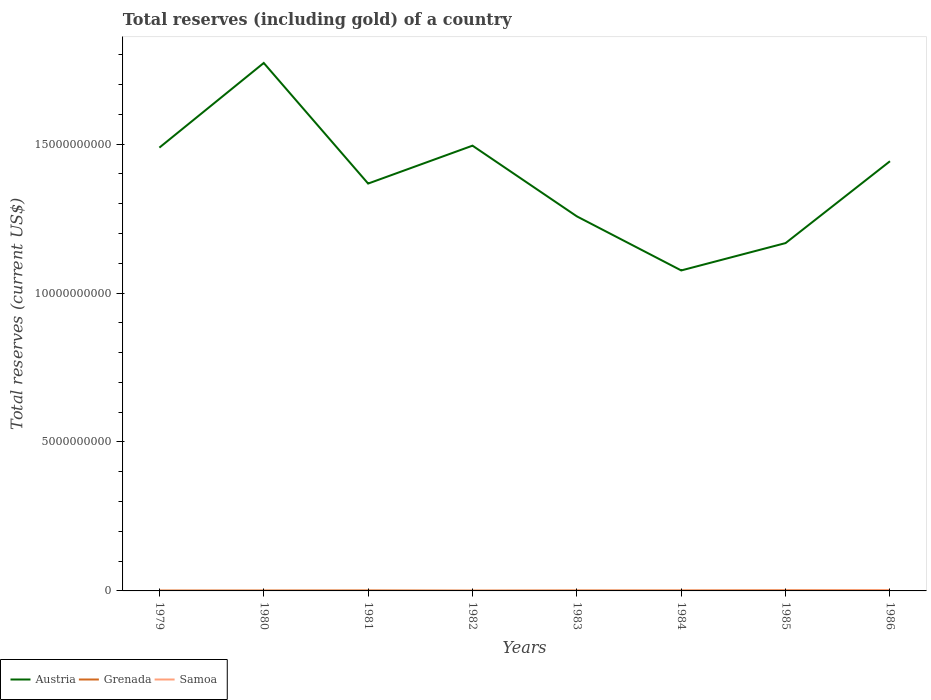How many different coloured lines are there?
Your answer should be very brief. 3. Does the line corresponding to Austria intersect with the line corresponding to Grenada?
Offer a very short reply. No. Is the number of lines equal to the number of legend labels?
Ensure brevity in your answer.  Yes. Across all years, what is the maximum total reserves (including gold) in Samoa?
Make the answer very short. 2.77e+06. What is the total total reserves (including gold) in Samoa in the graph?
Offer a very short reply. -4.46e+06. What is the difference between the highest and the second highest total reserves (including gold) in Austria?
Your answer should be very brief. 6.97e+09. What is the difference between the highest and the lowest total reserves (including gold) in Grenada?
Offer a very short reply. 3. How many years are there in the graph?
Provide a short and direct response. 8. Are the values on the major ticks of Y-axis written in scientific E-notation?
Make the answer very short. No. Does the graph contain any zero values?
Keep it short and to the point. No. Does the graph contain grids?
Keep it short and to the point. No. Where does the legend appear in the graph?
Ensure brevity in your answer.  Bottom left. What is the title of the graph?
Your answer should be compact. Total reserves (including gold) of a country. Does "Saudi Arabia" appear as one of the legend labels in the graph?
Your response must be concise. No. What is the label or title of the X-axis?
Your answer should be very brief. Years. What is the label or title of the Y-axis?
Your answer should be compact. Total reserves (current US$). What is the Total reserves (current US$) in Austria in 1979?
Your answer should be compact. 1.49e+1. What is the Total reserves (current US$) of Grenada in 1979?
Your answer should be compact. 1.22e+07. What is the Total reserves (current US$) in Samoa in 1979?
Provide a succinct answer. 4.82e+06. What is the Total reserves (current US$) of Austria in 1980?
Keep it short and to the point. 1.77e+1. What is the Total reserves (current US$) of Grenada in 1980?
Make the answer very short. 1.29e+07. What is the Total reserves (current US$) in Samoa in 1980?
Offer a very short reply. 2.77e+06. What is the Total reserves (current US$) of Austria in 1981?
Provide a succinct answer. 1.37e+1. What is the Total reserves (current US$) in Grenada in 1981?
Offer a very short reply. 1.61e+07. What is the Total reserves (current US$) in Samoa in 1981?
Ensure brevity in your answer.  3.28e+06. What is the Total reserves (current US$) in Austria in 1982?
Your answer should be very brief. 1.49e+1. What is the Total reserves (current US$) in Grenada in 1982?
Offer a terse response. 9.23e+06. What is the Total reserves (current US$) in Samoa in 1982?
Make the answer very short. 3.48e+06. What is the Total reserves (current US$) of Austria in 1983?
Make the answer very short. 1.26e+1. What is the Total reserves (current US$) in Grenada in 1983?
Make the answer very short. 1.41e+07. What is the Total reserves (current US$) of Samoa in 1983?
Your answer should be very brief. 7.23e+06. What is the Total reserves (current US$) of Austria in 1984?
Make the answer very short. 1.08e+1. What is the Total reserves (current US$) in Grenada in 1984?
Your response must be concise. 1.42e+07. What is the Total reserves (current US$) of Samoa in 1984?
Provide a short and direct response. 1.06e+07. What is the Total reserves (current US$) of Austria in 1985?
Make the answer very short. 1.17e+1. What is the Total reserves (current US$) in Grenada in 1985?
Your answer should be compact. 2.08e+07. What is the Total reserves (current US$) of Samoa in 1985?
Your response must be concise. 1.40e+07. What is the Total reserves (current US$) in Austria in 1986?
Make the answer very short. 1.44e+1. What is the Total reserves (current US$) in Grenada in 1986?
Provide a short and direct response. 2.06e+07. What is the Total reserves (current US$) of Samoa in 1986?
Offer a terse response. 2.37e+07. Across all years, what is the maximum Total reserves (current US$) in Austria?
Your answer should be very brief. 1.77e+1. Across all years, what is the maximum Total reserves (current US$) in Grenada?
Offer a terse response. 2.08e+07. Across all years, what is the maximum Total reserves (current US$) of Samoa?
Your answer should be very brief. 2.37e+07. Across all years, what is the minimum Total reserves (current US$) of Austria?
Offer a very short reply. 1.08e+1. Across all years, what is the minimum Total reserves (current US$) of Grenada?
Offer a very short reply. 9.23e+06. Across all years, what is the minimum Total reserves (current US$) of Samoa?
Ensure brevity in your answer.  2.77e+06. What is the total Total reserves (current US$) of Austria in the graph?
Provide a succinct answer. 1.11e+11. What is the total Total reserves (current US$) in Grenada in the graph?
Your response must be concise. 1.20e+08. What is the total Total reserves (current US$) of Samoa in the graph?
Make the answer very short. 6.99e+07. What is the difference between the Total reserves (current US$) of Austria in 1979 and that in 1980?
Your response must be concise. -2.84e+09. What is the difference between the Total reserves (current US$) of Grenada in 1979 and that in 1980?
Your answer should be compact. -6.89e+05. What is the difference between the Total reserves (current US$) of Samoa in 1979 and that in 1980?
Keep it short and to the point. 2.05e+06. What is the difference between the Total reserves (current US$) in Austria in 1979 and that in 1981?
Give a very brief answer. 1.21e+09. What is the difference between the Total reserves (current US$) in Grenada in 1979 and that in 1981?
Keep it short and to the point. -3.88e+06. What is the difference between the Total reserves (current US$) of Samoa in 1979 and that in 1981?
Offer a terse response. 1.54e+06. What is the difference between the Total reserves (current US$) of Austria in 1979 and that in 1982?
Offer a terse response. -6.56e+07. What is the difference between the Total reserves (current US$) in Grenada in 1979 and that in 1982?
Ensure brevity in your answer.  2.99e+06. What is the difference between the Total reserves (current US$) in Samoa in 1979 and that in 1982?
Ensure brevity in your answer.  1.34e+06. What is the difference between the Total reserves (current US$) of Austria in 1979 and that in 1983?
Offer a very short reply. 2.31e+09. What is the difference between the Total reserves (current US$) of Grenada in 1979 and that in 1983?
Your response must be concise. -1.92e+06. What is the difference between the Total reserves (current US$) of Samoa in 1979 and that in 1983?
Your response must be concise. -2.41e+06. What is the difference between the Total reserves (current US$) of Austria in 1979 and that in 1984?
Your answer should be compact. 4.12e+09. What is the difference between the Total reserves (current US$) of Grenada in 1979 and that in 1984?
Provide a succinct answer. -2.01e+06. What is the difference between the Total reserves (current US$) of Samoa in 1979 and that in 1984?
Offer a terse response. -5.74e+06. What is the difference between the Total reserves (current US$) of Austria in 1979 and that in 1985?
Provide a short and direct response. 3.21e+09. What is the difference between the Total reserves (current US$) of Grenada in 1979 and that in 1985?
Provide a short and direct response. -8.59e+06. What is the difference between the Total reserves (current US$) in Samoa in 1979 and that in 1985?
Make the answer very short. -9.20e+06. What is the difference between the Total reserves (current US$) of Austria in 1979 and that in 1986?
Your response must be concise. 4.57e+08. What is the difference between the Total reserves (current US$) of Grenada in 1979 and that in 1986?
Provide a short and direct response. -8.35e+06. What is the difference between the Total reserves (current US$) in Samoa in 1979 and that in 1986?
Give a very brief answer. -1.89e+07. What is the difference between the Total reserves (current US$) in Austria in 1980 and that in 1981?
Make the answer very short. 4.05e+09. What is the difference between the Total reserves (current US$) in Grenada in 1980 and that in 1981?
Provide a succinct answer. -3.19e+06. What is the difference between the Total reserves (current US$) in Samoa in 1980 and that in 1981?
Provide a short and direct response. -5.12e+05. What is the difference between the Total reserves (current US$) of Austria in 1980 and that in 1982?
Provide a succinct answer. 2.78e+09. What is the difference between the Total reserves (current US$) in Grenada in 1980 and that in 1982?
Provide a short and direct response. 3.68e+06. What is the difference between the Total reserves (current US$) in Samoa in 1980 and that in 1982?
Provide a short and direct response. -7.11e+05. What is the difference between the Total reserves (current US$) in Austria in 1980 and that in 1983?
Offer a terse response. 5.15e+09. What is the difference between the Total reserves (current US$) in Grenada in 1980 and that in 1983?
Ensure brevity in your answer.  -1.23e+06. What is the difference between the Total reserves (current US$) in Samoa in 1980 and that in 1983?
Your answer should be very brief. -4.46e+06. What is the difference between the Total reserves (current US$) in Austria in 1980 and that in 1984?
Keep it short and to the point. 6.97e+09. What is the difference between the Total reserves (current US$) in Grenada in 1980 and that in 1984?
Offer a very short reply. -1.33e+06. What is the difference between the Total reserves (current US$) in Samoa in 1980 and that in 1984?
Offer a terse response. -7.79e+06. What is the difference between the Total reserves (current US$) in Austria in 1980 and that in 1985?
Make the answer very short. 6.05e+09. What is the difference between the Total reserves (current US$) of Grenada in 1980 and that in 1985?
Give a very brief answer. -7.90e+06. What is the difference between the Total reserves (current US$) in Samoa in 1980 and that in 1985?
Give a very brief answer. -1.13e+07. What is the difference between the Total reserves (current US$) of Austria in 1980 and that in 1986?
Offer a terse response. 3.30e+09. What is the difference between the Total reserves (current US$) in Grenada in 1980 and that in 1986?
Offer a terse response. -7.66e+06. What is the difference between the Total reserves (current US$) in Samoa in 1980 and that in 1986?
Offer a very short reply. -2.10e+07. What is the difference between the Total reserves (current US$) of Austria in 1981 and that in 1982?
Ensure brevity in your answer.  -1.27e+09. What is the difference between the Total reserves (current US$) of Grenada in 1981 and that in 1982?
Offer a terse response. 6.86e+06. What is the difference between the Total reserves (current US$) in Samoa in 1981 and that in 1982?
Provide a short and direct response. -1.99e+05. What is the difference between the Total reserves (current US$) of Austria in 1981 and that in 1983?
Your answer should be compact. 1.10e+09. What is the difference between the Total reserves (current US$) in Grenada in 1981 and that in 1983?
Make the answer very short. 1.96e+06. What is the difference between the Total reserves (current US$) in Samoa in 1981 and that in 1983?
Your response must be concise. -3.95e+06. What is the difference between the Total reserves (current US$) in Austria in 1981 and that in 1984?
Offer a terse response. 2.92e+09. What is the difference between the Total reserves (current US$) in Grenada in 1981 and that in 1984?
Your answer should be compact. 1.86e+06. What is the difference between the Total reserves (current US$) in Samoa in 1981 and that in 1984?
Your answer should be compact. -7.28e+06. What is the difference between the Total reserves (current US$) of Austria in 1981 and that in 1985?
Offer a terse response. 2.00e+09. What is the difference between the Total reserves (current US$) of Grenada in 1981 and that in 1985?
Your response must be concise. -4.72e+06. What is the difference between the Total reserves (current US$) in Samoa in 1981 and that in 1985?
Provide a short and direct response. -1.07e+07. What is the difference between the Total reserves (current US$) in Austria in 1981 and that in 1986?
Your response must be concise. -7.50e+08. What is the difference between the Total reserves (current US$) of Grenada in 1981 and that in 1986?
Your response must be concise. -4.47e+06. What is the difference between the Total reserves (current US$) in Samoa in 1981 and that in 1986?
Offer a very short reply. -2.05e+07. What is the difference between the Total reserves (current US$) in Austria in 1982 and that in 1983?
Keep it short and to the point. 2.37e+09. What is the difference between the Total reserves (current US$) of Grenada in 1982 and that in 1983?
Keep it short and to the point. -4.91e+06. What is the difference between the Total reserves (current US$) of Samoa in 1982 and that in 1983?
Provide a short and direct response. -3.75e+06. What is the difference between the Total reserves (current US$) of Austria in 1982 and that in 1984?
Provide a succinct answer. 4.19e+09. What is the difference between the Total reserves (current US$) in Grenada in 1982 and that in 1984?
Provide a succinct answer. -5.00e+06. What is the difference between the Total reserves (current US$) of Samoa in 1982 and that in 1984?
Your answer should be compact. -7.08e+06. What is the difference between the Total reserves (current US$) of Austria in 1982 and that in 1985?
Ensure brevity in your answer.  3.27e+09. What is the difference between the Total reserves (current US$) in Grenada in 1982 and that in 1985?
Your response must be concise. -1.16e+07. What is the difference between the Total reserves (current US$) in Samoa in 1982 and that in 1985?
Give a very brief answer. -1.05e+07. What is the difference between the Total reserves (current US$) in Austria in 1982 and that in 1986?
Keep it short and to the point. 5.22e+08. What is the difference between the Total reserves (current US$) in Grenada in 1982 and that in 1986?
Give a very brief answer. -1.13e+07. What is the difference between the Total reserves (current US$) in Samoa in 1982 and that in 1986?
Offer a terse response. -2.03e+07. What is the difference between the Total reserves (current US$) in Austria in 1983 and that in 1984?
Provide a short and direct response. 1.82e+09. What is the difference between the Total reserves (current US$) of Grenada in 1983 and that in 1984?
Your answer should be very brief. -9.27e+04. What is the difference between the Total reserves (current US$) of Samoa in 1983 and that in 1984?
Offer a terse response. -3.33e+06. What is the difference between the Total reserves (current US$) of Austria in 1983 and that in 1985?
Ensure brevity in your answer.  8.97e+08. What is the difference between the Total reserves (current US$) of Grenada in 1983 and that in 1985?
Provide a short and direct response. -6.67e+06. What is the difference between the Total reserves (current US$) in Samoa in 1983 and that in 1985?
Make the answer very short. -6.79e+06. What is the difference between the Total reserves (current US$) of Austria in 1983 and that in 1986?
Provide a short and direct response. -1.85e+09. What is the difference between the Total reserves (current US$) in Grenada in 1983 and that in 1986?
Offer a terse response. -6.42e+06. What is the difference between the Total reserves (current US$) of Samoa in 1983 and that in 1986?
Provide a succinct answer. -1.65e+07. What is the difference between the Total reserves (current US$) in Austria in 1984 and that in 1985?
Your response must be concise. -9.19e+08. What is the difference between the Total reserves (current US$) in Grenada in 1984 and that in 1985?
Offer a terse response. -6.58e+06. What is the difference between the Total reserves (current US$) in Samoa in 1984 and that in 1985?
Offer a very short reply. -3.46e+06. What is the difference between the Total reserves (current US$) in Austria in 1984 and that in 1986?
Provide a succinct answer. -3.67e+09. What is the difference between the Total reserves (current US$) in Grenada in 1984 and that in 1986?
Your answer should be compact. -6.33e+06. What is the difference between the Total reserves (current US$) of Samoa in 1984 and that in 1986?
Offer a very short reply. -1.32e+07. What is the difference between the Total reserves (current US$) of Austria in 1985 and that in 1986?
Keep it short and to the point. -2.75e+09. What is the difference between the Total reserves (current US$) of Grenada in 1985 and that in 1986?
Keep it short and to the point. 2.47e+05. What is the difference between the Total reserves (current US$) of Samoa in 1985 and that in 1986?
Offer a terse response. -9.73e+06. What is the difference between the Total reserves (current US$) in Austria in 1979 and the Total reserves (current US$) in Grenada in 1980?
Offer a terse response. 1.49e+1. What is the difference between the Total reserves (current US$) in Austria in 1979 and the Total reserves (current US$) in Samoa in 1980?
Your answer should be compact. 1.49e+1. What is the difference between the Total reserves (current US$) in Grenada in 1979 and the Total reserves (current US$) in Samoa in 1980?
Ensure brevity in your answer.  9.45e+06. What is the difference between the Total reserves (current US$) of Austria in 1979 and the Total reserves (current US$) of Grenada in 1981?
Give a very brief answer. 1.49e+1. What is the difference between the Total reserves (current US$) in Austria in 1979 and the Total reserves (current US$) in Samoa in 1981?
Make the answer very short. 1.49e+1. What is the difference between the Total reserves (current US$) of Grenada in 1979 and the Total reserves (current US$) of Samoa in 1981?
Your response must be concise. 8.94e+06. What is the difference between the Total reserves (current US$) of Austria in 1979 and the Total reserves (current US$) of Grenada in 1982?
Ensure brevity in your answer.  1.49e+1. What is the difference between the Total reserves (current US$) in Austria in 1979 and the Total reserves (current US$) in Samoa in 1982?
Your answer should be compact. 1.49e+1. What is the difference between the Total reserves (current US$) in Grenada in 1979 and the Total reserves (current US$) in Samoa in 1982?
Offer a very short reply. 8.74e+06. What is the difference between the Total reserves (current US$) in Austria in 1979 and the Total reserves (current US$) in Grenada in 1983?
Make the answer very short. 1.49e+1. What is the difference between the Total reserves (current US$) of Austria in 1979 and the Total reserves (current US$) of Samoa in 1983?
Your answer should be compact. 1.49e+1. What is the difference between the Total reserves (current US$) of Grenada in 1979 and the Total reserves (current US$) of Samoa in 1983?
Make the answer very short. 4.99e+06. What is the difference between the Total reserves (current US$) in Austria in 1979 and the Total reserves (current US$) in Grenada in 1984?
Provide a succinct answer. 1.49e+1. What is the difference between the Total reserves (current US$) of Austria in 1979 and the Total reserves (current US$) of Samoa in 1984?
Offer a terse response. 1.49e+1. What is the difference between the Total reserves (current US$) of Grenada in 1979 and the Total reserves (current US$) of Samoa in 1984?
Provide a succinct answer. 1.66e+06. What is the difference between the Total reserves (current US$) in Austria in 1979 and the Total reserves (current US$) in Grenada in 1985?
Make the answer very short. 1.49e+1. What is the difference between the Total reserves (current US$) in Austria in 1979 and the Total reserves (current US$) in Samoa in 1985?
Keep it short and to the point. 1.49e+1. What is the difference between the Total reserves (current US$) in Grenada in 1979 and the Total reserves (current US$) in Samoa in 1985?
Make the answer very short. -1.80e+06. What is the difference between the Total reserves (current US$) of Austria in 1979 and the Total reserves (current US$) of Grenada in 1986?
Offer a very short reply. 1.49e+1. What is the difference between the Total reserves (current US$) of Austria in 1979 and the Total reserves (current US$) of Samoa in 1986?
Offer a terse response. 1.49e+1. What is the difference between the Total reserves (current US$) of Grenada in 1979 and the Total reserves (current US$) of Samoa in 1986?
Your answer should be compact. -1.15e+07. What is the difference between the Total reserves (current US$) in Austria in 1980 and the Total reserves (current US$) in Grenada in 1981?
Provide a succinct answer. 1.77e+1. What is the difference between the Total reserves (current US$) in Austria in 1980 and the Total reserves (current US$) in Samoa in 1981?
Your response must be concise. 1.77e+1. What is the difference between the Total reserves (current US$) in Grenada in 1980 and the Total reserves (current US$) in Samoa in 1981?
Offer a terse response. 9.63e+06. What is the difference between the Total reserves (current US$) of Austria in 1980 and the Total reserves (current US$) of Grenada in 1982?
Keep it short and to the point. 1.77e+1. What is the difference between the Total reserves (current US$) of Austria in 1980 and the Total reserves (current US$) of Samoa in 1982?
Your answer should be compact. 1.77e+1. What is the difference between the Total reserves (current US$) in Grenada in 1980 and the Total reserves (current US$) in Samoa in 1982?
Your answer should be compact. 9.43e+06. What is the difference between the Total reserves (current US$) of Austria in 1980 and the Total reserves (current US$) of Grenada in 1983?
Ensure brevity in your answer.  1.77e+1. What is the difference between the Total reserves (current US$) of Austria in 1980 and the Total reserves (current US$) of Samoa in 1983?
Your answer should be compact. 1.77e+1. What is the difference between the Total reserves (current US$) of Grenada in 1980 and the Total reserves (current US$) of Samoa in 1983?
Offer a very short reply. 5.68e+06. What is the difference between the Total reserves (current US$) of Austria in 1980 and the Total reserves (current US$) of Grenada in 1984?
Provide a short and direct response. 1.77e+1. What is the difference between the Total reserves (current US$) in Austria in 1980 and the Total reserves (current US$) in Samoa in 1984?
Make the answer very short. 1.77e+1. What is the difference between the Total reserves (current US$) in Grenada in 1980 and the Total reserves (current US$) in Samoa in 1984?
Your answer should be very brief. 2.35e+06. What is the difference between the Total reserves (current US$) of Austria in 1980 and the Total reserves (current US$) of Grenada in 1985?
Your answer should be compact. 1.77e+1. What is the difference between the Total reserves (current US$) in Austria in 1980 and the Total reserves (current US$) in Samoa in 1985?
Offer a very short reply. 1.77e+1. What is the difference between the Total reserves (current US$) in Grenada in 1980 and the Total reserves (current US$) in Samoa in 1985?
Keep it short and to the point. -1.11e+06. What is the difference between the Total reserves (current US$) in Austria in 1980 and the Total reserves (current US$) in Grenada in 1986?
Offer a terse response. 1.77e+1. What is the difference between the Total reserves (current US$) in Austria in 1980 and the Total reserves (current US$) in Samoa in 1986?
Offer a very short reply. 1.77e+1. What is the difference between the Total reserves (current US$) of Grenada in 1980 and the Total reserves (current US$) of Samoa in 1986?
Your response must be concise. -1.08e+07. What is the difference between the Total reserves (current US$) in Austria in 1981 and the Total reserves (current US$) in Grenada in 1982?
Provide a succinct answer. 1.37e+1. What is the difference between the Total reserves (current US$) in Austria in 1981 and the Total reserves (current US$) in Samoa in 1982?
Keep it short and to the point. 1.37e+1. What is the difference between the Total reserves (current US$) in Grenada in 1981 and the Total reserves (current US$) in Samoa in 1982?
Your answer should be compact. 1.26e+07. What is the difference between the Total reserves (current US$) of Austria in 1981 and the Total reserves (current US$) of Grenada in 1983?
Offer a very short reply. 1.37e+1. What is the difference between the Total reserves (current US$) in Austria in 1981 and the Total reserves (current US$) in Samoa in 1983?
Give a very brief answer. 1.37e+1. What is the difference between the Total reserves (current US$) in Grenada in 1981 and the Total reserves (current US$) in Samoa in 1983?
Offer a terse response. 8.87e+06. What is the difference between the Total reserves (current US$) in Austria in 1981 and the Total reserves (current US$) in Grenada in 1984?
Give a very brief answer. 1.37e+1. What is the difference between the Total reserves (current US$) of Austria in 1981 and the Total reserves (current US$) of Samoa in 1984?
Provide a succinct answer. 1.37e+1. What is the difference between the Total reserves (current US$) in Grenada in 1981 and the Total reserves (current US$) in Samoa in 1984?
Provide a succinct answer. 5.54e+06. What is the difference between the Total reserves (current US$) in Austria in 1981 and the Total reserves (current US$) in Grenada in 1985?
Provide a succinct answer. 1.37e+1. What is the difference between the Total reserves (current US$) of Austria in 1981 and the Total reserves (current US$) of Samoa in 1985?
Make the answer very short. 1.37e+1. What is the difference between the Total reserves (current US$) of Grenada in 1981 and the Total reserves (current US$) of Samoa in 1985?
Make the answer very short. 2.08e+06. What is the difference between the Total reserves (current US$) in Austria in 1981 and the Total reserves (current US$) in Grenada in 1986?
Your answer should be compact. 1.37e+1. What is the difference between the Total reserves (current US$) of Austria in 1981 and the Total reserves (current US$) of Samoa in 1986?
Give a very brief answer. 1.37e+1. What is the difference between the Total reserves (current US$) of Grenada in 1981 and the Total reserves (current US$) of Samoa in 1986?
Give a very brief answer. -7.65e+06. What is the difference between the Total reserves (current US$) in Austria in 1982 and the Total reserves (current US$) in Grenada in 1983?
Your answer should be compact. 1.49e+1. What is the difference between the Total reserves (current US$) of Austria in 1982 and the Total reserves (current US$) of Samoa in 1983?
Your answer should be very brief. 1.49e+1. What is the difference between the Total reserves (current US$) in Grenada in 1982 and the Total reserves (current US$) in Samoa in 1983?
Offer a terse response. 2.00e+06. What is the difference between the Total reserves (current US$) of Austria in 1982 and the Total reserves (current US$) of Grenada in 1984?
Keep it short and to the point. 1.49e+1. What is the difference between the Total reserves (current US$) of Austria in 1982 and the Total reserves (current US$) of Samoa in 1984?
Your response must be concise. 1.49e+1. What is the difference between the Total reserves (current US$) of Grenada in 1982 and the Total reserves (current US$) of Samoa in 1984?
Give a very brief answer. -1.32e+06. What is the difference between the Total reserves (current US$) of Austria in 1982 and the Total reserves (current US$) of Grenada in 1985?
Provide a succinct answer. 1.49e+1. What is the difference between the Total reserves (current US$) of Austria in 1982 and the Total reserves (current US$) of Samoa in 1985?
Offer a very short reply. 1.49e+1. What is the difference between the Total reserves (current US$) in Grenada in 1982 and the Total reserves (current US$) in Samoa in 1985?
Provide a short and direct response. -4.79e+06. What is the difference between the Total reserves (current US$) in Austria in 1982 and the Total reserves (current US$) in Grenada in 1986?
Your response must be concise. 1.49e+1. What is the difference between the Total reserves (current US$) in Austria in 1982 and the Total reserves (current US$) in Samoa in 1986?
Keep it short and to the point. 1.49e+1. What is the difference between the Total reserves (current US$) of Grenada in 1982 and the Total reserves (current US$) of Samoa in 1986?
Provide a short and direct response. -1.45e+07. What is the difference between the Total reserves (current US$) in Austria in 1983 and the Total reserves (current US$) in Grenada in 1984?
Offer a terse response. 1.26e+1. What is the difference between the Total reserves (current US$) in Austria in 1983 and the Total reserves (current US$) in Samoa in 1984?
Your answer should be compact. 1.26e+1. What is the difference between the Total reserves (current US$) in Grenada in 1983 and the Total reserves (current US$) in Samoa in 1984?
Keep it short and to the point. 3.58e+06. What is the difference between the Total reserves (current US$) in Austria in 1983 and the Total reserves (current US$) in Grenada in 1985?
Keep it short and to the point. 1.26e+1. What is the difference between the Total reserves (current US$) of Austria in 1983 and the Total reserves (current US$) of Samoa in 1985?
Your response must be concise. 1.26e+1. What is the difference between the Total reserves (current US$) of Grenada in 1983 and the Total reserves (current US$) of Samoa in 1985?
Provide a succinct answer. 1.21e+05. What is the difference between the Total reserves (current US$) of Austria in 1983 and the Total reserves (current US$) of Grenada in 1986?
Your answer should be very brief. 1.26e+1. What is the difference between the Total reserves (current US$) of Austria in 1983 and the Total reserves (current US$) of Samoa in 1986?
Offer a very short reply. 1.26e+1. What is the difference between the Total reserves (current US$) in Grenada in 1983 and the Total reserves (current US$) in Samoa in 1986?
Provide a succinct answer. -9.60e+06. What is the difference between the Total reserves (current US$) in Austria in 1984 and the Total reserves (current US$) in Grenada in 1985?
Ensure brevity in your answer.  1.07e+1. What is the difference between the Total reserves (current US$) in Austria in 1984 and the Total reserves (current US$) in Samoa in 1985?
Offer a terse response. 1.07e+1. What is the difference between the Total reserves (current US$) of Grenada in 1984 and the Total reserves (current US$) of Samoa in 1985?
Offer a very short reply. 2.13e+05. What is the difference between the Total reserves (current US$) in Austria in 1984 and the Total reserves (current US$) in Grenada in 1986?
Provide a short and direct response. 1.07e+1. What is the difference between the Total reserves (current US$) of Austria in 1984 and the Total reserves (current US$) of Samoa in 1986?
Make the answer very short. 1.07e+1. What is the difference between the Total reserves (current US$) in Grenada in 1984 and the Total reserves (current US$) in Samoa in 1986?
Make the answer very short. -9.51e+06. What is the difference between the Total reserves (current US$) of Austria in 1985 and the Total reserves (current US$) of Grenada in 1986?
Keep it short and to the point. 1.17e+1. What is the difference between the Total reserves (current US$) of Austria in 1985 and the Total reserves (current US$) of Samoa in 1986?
Give a very brief answer. 1.17e+1. What is the difference between the Total reserves (current US$) in Grenada in 1985 and the Total reserves (current US$) in Samoa in 1986?
Provide a succinct answer. -2.93e+06. What is the average Total reserves (current US$) of Austria per year?
Provide a short and direct response. 1.38e+1. What is the average Total reserves (current US$) in Grenada per year?
Ensure brevity in your answer.  1.50e+07. What is the average Total reserves (current US$) in Samoa per year?
Your answer should be very brief. 8.74e+06. In the year 1979, what is the difference between the Total reserves (current US$) in Austria and Total reserves (current US$) in Grenada?
Your answer should be compact. 1.49e+1. In the year 1979, what is the difference between the Total reserves (current US$) of Austria and Total reserves (current US$) of Samoa?
Ensure brevity in your answer.  1.49e+1. In the year 1979, what is the difference between the Total reserves (current US$) of Grenada and Total reserves (current US$) of Samoa?
Give a very brief answer. 7.40e+06. In the year 1980, what is the difference between the Total reserves (current US$) of Austria and Total reserves (current US$) of Grenada?
Offer a very short reply. 1.77e+1. In the year 1980, what is the difference between the Total reserves (current US$) of Austria and Total reserves (current US$) of Samoa?
Your answer should be very brief. 1.77e+1. In the year 1980, what is the difference between the Total reserves (current US$) in Grenada and Total reserves (current US$) in Samoa?
Offer a terse response. 1.01e+07. In the year 1981, what is the difference between the Total reserves (current US$) of Austria and Total reserves (current US$) of Grenada?
Make the answer very short. 1.37e+1. In the year 1981, what is the difference between the Total reserves (current US$) of Austria and Total reserves (current US$) of Samoa?
Your answer should be very brief. 1.37e+1. In the year 1981, what is the difference between the Total reserves (current US$) in Grenada and Total reserves (current US$) in Samoa?
Your answer should be very brief. 1.28e+07. In the year 1982, what is the difference between the Total reserves (current US$) in Austria and Total reserves (current US$) in Grenada?
Provide a short and direct response. 1.49e+1. In the year 1982, what is the difference between the Total reserves (current US$) in Austria and Total reserves (current US$) in Samoa?
Keep it short and to the point. 1.49e+1. In the year 1982, what is the difference between the Total reserves (current US$) of Grenada and Total reserves (current US$) of Samoa?
Keep it short and to the point. 5.75e+06. In the year 1983, what is the difference between the Total reserves (current US$) in Austria and Total reserves (current US$) in Grenada?
Your answer should be very brief. 1.26e+1. In the year 1983, what is the difference between the Total reserves (current US$) of Austria and Total reserves (current US$) of Samoa?
Provide a succinct answer. 1.26e+1. In the year 1983, what is the difference between the Total reserves (current US$) of Grenada and Total reserves (current US$) of Samoa?
Provide a short and direct response. 6.91e+06. In the year 1984, what is the difference between the Total reserves (current US$) of Austria and Total reserves (current US$) of Grenada?
Make the answer very short. 1.07e+1. In the year 1984, what is the difference between the Total reserves (current US$) of Austria and Total reserves (current US$) of Samoa?
Your answer should be very brief. 1.07e+1. In the year 1984, what is the difference between the Total reserves (current US$) in Grenada and Total reserves (current US$) in Samoa?
Offer a terse response. 3.68e+06. In the year 1985, what is the difference between the Total reserves (current US$) in Austria and Total reserves (current US$) in Grenada?
Make the answer very short. 1.17e+1. In the year 1985, what is the difference between the Total reserves (current US$) of Austria and Total reserves (current US$) of Samoa?
Make the answer very short. 1.17e+1. In the year 1985, what is the difference between the Total reserves (current US$) of Grenada and Total reserves (current US$) of Samoa?
Your answer should be compact. 6.79e+06. In the year 1986, what is the difference between the Total reserves (current US$) in Austria and Total reserves (current US$) in Grenada?
Your response must be concise. 1.44e+1. In the year 1986, what is the difference between the Total reserves (current US$) of Austria and Total reserves (current US$) of Samoa?
Provide a succinct answer. 1.44e+1. In the year 1986, what is the difference between the Total reserves (current US$) of Grenada and Total reserves (current US$) of Samoa?
Offer a very short reply. -3.18e+06. What is the ratio of the Total reserves (current US$) in Austria in 1979 to that in 1980?
Offer a terse response. 0.84. What is the ratio of the Total reserves (current US$) of Grenada in 1979 to that in 1980?
Make the answer very short. 0.95. What is the ratio of the Total reserves (current US$) in Samoa in 1979 to that in 1980?
Ensure brevity in your answer.  1.74. What is the ratio of the Total reserves (current US$) of Austria in 1979 to that in 1981?
Make the answer very short. 1.09. What is the ratio of the Total reserves (current US$) in Grenada in 1979 to that in 1981?
Provide a short and direct response. 0.76. What is the ratio of the Total reserves (current US$) of Samoa in 1979 to that in 1981?
Offer a very short reply. 1.47. What is the ratio of the Total reserves (current US$) in Grenada in 1979 to that in 1982?
Offer a very short reply. 1.32. What is the ratio of the Total reserves (current US$) of Samoa in 1979 to that in 1982?
Your response must be concise. 1.38. What is the ratio of the Total reserves (current US$) of Austria in 1979 to that in 1983?
Offer a terse response. 1.18. What is the ratio of the Total reserves (current US$) in Grenada in 1979 to that in 1983?
Offer a very short reply. 0.86. What is the ratio of the Total reserves (current US$) of Samoa in 1979 to that in 1983?
Keep it short and to the point. 0.67. What is the ratio of the Total reserves (current US$) in Austria in 1979 to that in 1984?
Your answer should be very brief. 1.38. What is the ratio of the Total reserves (current US$) of Grenada in 1979 to that in 1984?
Make the answer very short. 0.86. What is the ratio of the Total reserves (current US$) of Samoa in 1979 to that in 1984?
Provide a succinct answer. 0.46. What is the ratio of the Total reserves (current US$) in Austria in 1979 to that in 1985?
Provide a succinct answer. 1.27. What is the ratio of the Total reserves (current US$) of Grenada in 1979 to that in 1985?
Provide a short and direct response. 0.59. What is the ratio of the Total reserves (current US$) of Samoa in 1979 to that in 1985?
Your answer should be compact. 0.34. What is the ratio of the Total reserves (current US$) of Austria in 1979 to that in 1986?
Offer a terse response. 1.03. What is the ratio of the Total reserves (current US$) of Grenada in 1979 to that in 1986?
Offer a terse response. 0.59. What is the ratio of the Total reserves (current US$) in Samoa in 1979 to that in 1986?
Keep it short and to the point. 0.2. What is the ratio of the Total reserves (current US$) in Austria in 1980 to that in 1981?
Keep it short and to the point. 1.3. What is the ratio of the Total reserves (current US$) in Grenada in 1980 to that in 1981?
Provide a succinct answer. 0.8. What is the ratio of the Total reserves (current US$) of Samoa in 1980 to that in 1981?
Provide a succinct answer. 0.84. What is the ratio of the Total reserves (current US$) of Austria in 1980 to that in 1982?
Make the answer very short. 1.19. What is the ratio of the Total reserves (current US$) of Grenada in 1980 to that in 1982?
Offer a terse response. 1.4. What is the ratio of the Total reserves (current US$) in Samoa in 1980 to that in 1982?
Offer a very short reply. 0.8. What is the ratio of the Total reserves (current US$) of Austria in 1980 to that in 1983?
Make the answer very short. 1.41. What is the ratio of the Total reserves (current US$) of Grenada in 1980 to that in 1983?
Your answer should be compact. 0.91. What is the ratio of the Total reserves (current US$) of Samoa in 1980 to that in 1983?
Your answer should be compact. 0.38. What is the ratio of the Total reserves (current US$) in Austria in 1980 to that in 1984?
Give a very brief answer. 1.65. What is the ratio of the Total reserves (current US$) in Grenada in 1980 to that in 1984?
Offer a very short reply. 0.91. What is the ratio of the Total reserves (current US$) in Samoa in 1980 to that in 1984?
Your answer should be very brief. 0.26. What is the ratio of the Total reserves (current US$) in Austria in 1980 to that in 1985?
Keep it short and to the point. 1.52. What is the ratio of the Total reserves (current US$) in Grenada in 1980 to that in 1985?
Provide a succinct answer. 0.62. What is the ratio of the Total reserves (current US$) of Samoa in 1980 to that in 1985?
Offer a terse response. 0.2. What is the ratio of the Total reserves (current US$) in Austria in 1980 to that in 1986?
Offer a very short reply. 1.23. What is the ratio of the Total reserves (current US$) in Grenada in 1980 to that in 1986?
Your response must be concise. 0.63. What is the ratio of the Total reserves (current US$) of Samoa in 1980 to that in 1986?
Keep it short and to the point. 0.12. What is the ratio of the Total reserves (current US$) in Austria in 1981 to that in 1982?
Ensure brevity in your answer.  0.91. What is the ratio of the Total reserves (current US$) in Grenada in 1981 to that in 1982?
Your response must be concise. 1.74. What is the ratio of the Total reserves (current US$) in Samoa in 1981 to that in 1982?
Give a very brief answer. 0.94. What is the ratio of the Total reserves (current US$) in Austria in 1981 to that in 1983?
Offer a terse response. 1.09. What is the ratio of the Total reserves (current US$) of Grenada in 1981 to that in 1983?
Make the answer very short. 1.14. What is the ratio of the Total reserves (current US$) of Samoa in 1981 to that in 1983?
Your response must be concise. 0.45. What is the ratio of the Total reserves (current US$) in Austria in 1981 to that in 1984?
Make the answer very short. 1.27. What is the ratio of the Total reserves (current US$) in Grenada in 1981 to that in 1984?
Ensure brevity in your answer.  1.13. What is the ratio of the Total reserves (current US$) of Samoa in 1981 to that in 1984?
Your response must be concise. 0.31. What is the ratio of the Total reserves (current US$) in Austria in 1981 to that in 1985?
Your answer should be compact. 1.17. What is the ratio of the Total reserves (current US$) in Grenada in 1981 to that in 1985?
Provide a succinct answer. 0.77. What is the ratio of the Total reserves (current US$) of Samoa in 1981 to that in 1985?
Offer a very short reply. 0.23. What is the ratio of the Total reserves (current US$) of Austria in 1981 to that in 1986?
Your answer should be very brief. 0.95. What is the ratio of the Total reserves (current US$) of Grenada in 1981 to that in 1986?
Keep it short and to the point. 0.78. What is the ratio of the Total reserves (current US$) of Samoa in 1981 to that in 1986?
Provide a short and direct response. 0.14. What is the ratio of the Total reserves (current US$) in Austria in 1982 to that in 1983?
Your response must be concise. 1.19. What is the ratio of the Total reserves (current US$) of Grenada in 1982 to that in 1983?
Offer a terse response. 0.65. What is the ratio of the Total reserves (current US$) in Samoa in 1982 to that in 1983?
Your answer should be very brief. 0.48. What is the ratio of the Total reserves (current US$) in Austria in 1982 to that in 1984?
Give a very brief answer. 1.39. What is the ratio of the Total reserves (current US$) in Grenada in 1982 to that in 1984?
Ensure brevity in your answer.  0.65. What is the ratio of the Total reserves (current US$) in Samoa in 1982 to that in 1984?
Provide a succinct answer. 0.33. What is the ratio of the Total reserves (current US$) of Austria in 1982 to that in 1985?
Your response must be concise. 1.28. What is the ratio of the Total reserves (current US$) in Grenada in 1982 to that in 1985?
Provide a short and direct response. 0.44. What is the ratio of the Total reserves (current US$) of Samoa in 1982 to that in 1985?
Make the answer very short. 0.25. What is the ratio of the Total reserves (current US$) in Austria in 1982 to that in 1986?
Offer a very short reply. 1.04. What is the ratio of the Total reserves (current US$) of Grenada in 1982 to that in 1986?
Provide a short and direct response. 0.45. What is the ratio of the Total reserves (current US$) of Samoa in 1982 to that in 1986?
Give a very brief answer. 0.15. What is the ratio of the Total reserves (current US$) of Austria in 1983 to that in 1984?
Your answer should be very brief. 1.17. What is the ratio of the Total reserves (current US$) in Samoa in 1983 to that in 1984?
Provide a succinct answer. 0.68. What is the ratio of the Total reserves (current US$) of Austria in 1983 to that in 1985?
Your response must be concise. 1.08. What is the ratio of the Total reserves (current US$) of Grenada in 1983 to that in 1985?
Ensure brevity in your answer.  0.68. What is the ratio of the Total reserves (current US$) of Samoa in 1983 to that in 1985?
Offer a terse response. 0.52. What is the ratio of the Total reserves (current US$) in Austria in 1983 to that in 1986?
Offer a terse response. 0.87. What is the ratio of the Total reserves (current US$) of Grenada in 1983 to that in 1986?
Offer a terse response. 0.69. What is the ratio of the Total reserves (current US$) of Samoa in 1983 to that in 1986?
Offer a terse response. 0.3. What is the ratio of the Total reserves (current US$) in Austria in 1984 to that in 1985?
Your response must be concise. 0.92. What is the ratio of the Total reserves (current US$) in Grenada in 1984 to that in 1985?
Provide a succinct answer. 0.68. What is the ratio of the Total reserves (current US$) in Samoa in 1984 to that in 1985?
Give a very brief answer. 0.75. What is the ratio of the Total reserves (current US$) in Austria in 1984 to that in 1986?
Offer a terse response. 0.75. What is the ratio of the Total reserves (current US$) of Grenada in 1984 to that in 1986?
Your answer should be very brief. 0.69. What is the ratio of the Total reserves (current US$) of Samoa in 1984 to that in 1986?
Offer a very short reply. 0.44. What is the ratio of the Total reserves (current US$) in Austria in 1985 to that in 1986?
Provide a succinct answer. 0.81. What is the ratio of the Total reserves (current US$) of Samoa in 1985 to that in 1986?
Provide a short and direct response. 0.59. What is the difference between the highest and the second highest Total reserves (current US$) in Austria?
Keep it short and to the point. 2.78e+09. What is the difference between the highest and the second highest Total reserves (current US$) in Grenada?
Your answer should be very brief. 2.47e+05. What is the difference between the highest and the second highest Total reserves (current US$) of Samoa?
Provide a short and direct response. 9.73e+06. What is the difference between the highest and the lowest Total reserves (current US$) of Austria?
Make the answer very short. 6.97e+09. What is the difference between the highest and the lowest Total reserves (current US$) in Grenada?
Give a very brief answer. 1.16e+07. What is the difference between the highest and the lowest Total reserves (current US$) of Samoa?
Keep it short and to the point. 2.10e+07. 